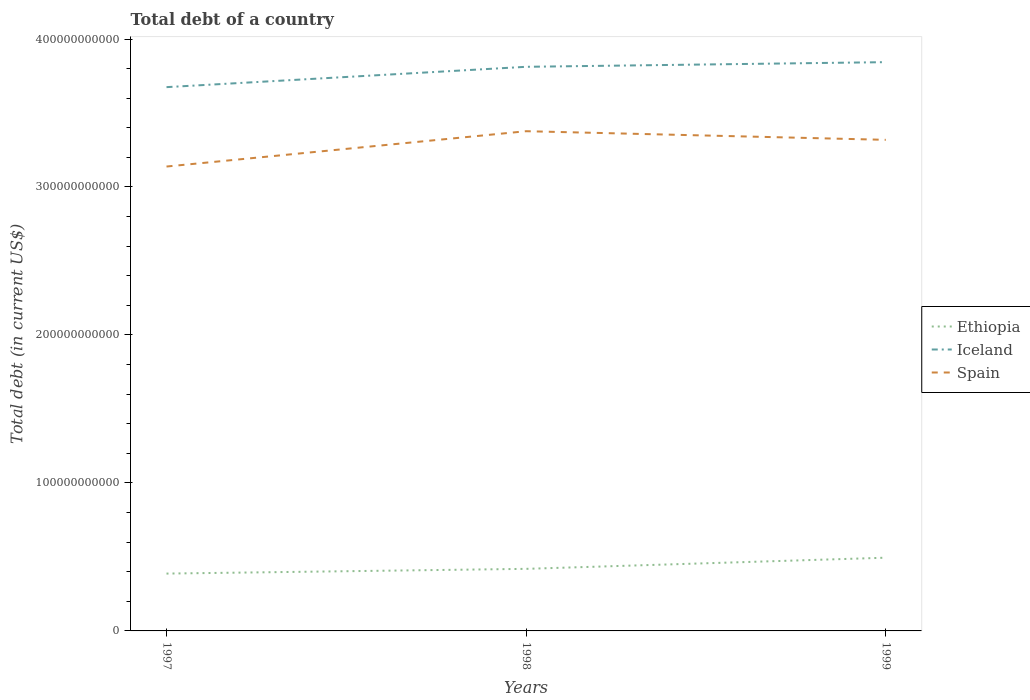Does the line corresponding to Spain intersect with the line corresponding to Ethiopia?
Provide a short and direct response. No. Is the number of lines equal to the number of legend labels?
Offer a very short reply. Yes. Across all years, what is the maximum debt in Iceland?
Offer a terse response. 3.67e+11. In which year was the debt in Spain maximum?
Provide a succinct answer. 1997. What is the total debt in Ethiopia in the graph?
Ensure brevity in your answer.  -7.54e+09. What is the difference between the highest and the second highest debt in Iceland?
Your response must be concise. 1.69e+1. What is the difference between the highest and the lowest debt in Ethiopia?
Provide a short and direct response. 1. How many lines are there?
Offer a very short reply. 3. How many years are there in the graph?
Provide a short and direct response. 3. What is the difference between two consecutive major ticks on the Y-axis?
Your answer should be very brief. 1.00e+11. Does the graph contain grids?
Provide a short and direct response. No. Where does the legend appear in the graph?
Your response must be concise. Center right. What is the title of the graph?
Your answer should be very brief. Total debt of a country. Does "Tajikistan" appear as one of the legend labels in the graph?
Your response must be concise. No. What is the label or title of the X-axis?
Keep it short and to the point. Years. What is the label or title of the Y-axis?
Your response must be concise. Total debt (in current US$). What is the Total debt (in current US$) in Ethiopia in 1997?
Give a very brief answer. 3.87e+1. What is the Total debt (in current US$) in Iceland in 1997?
Give a very brief answer. 3.67e+11. What is the Total debt (in current US$) in Spain in 1997?
Offer a terse response. 3.14e+11. What is the Total debt (in current US$) of Ethiopia in 1998?
Keep it short and to the point. 4.19e+1. What is the Total debt (in current US$) of Iceland in 1998?
Offer a very short reply. 3.81e+11. What is the Total debt (in current US$) of Spain in 1998?
Ensure brevity in your answer.  3.38e+11. What is the Total debt (in current US$) of Ethiopia in 1999?
Your answer should be compact. 4.95e+1. What is the Total debt (in current US$) of Iceland in 1999?
Keep it short and to the point. 3.84e+11. What is the Total debt (in current US$) of Spain in 1999?
Ensure brevity in your answer.  3.32e+11. Across all years, what is the maximum Total debt (in current US$) in Ethiopia?
Offer a very short reply. 4.95e+1. Across all years, what is the maximum Total debt (in current US$) in Iceland?
Your answer should be compact. 3.84e+11. Across all years, what is the maximum Total debt (in current US$) of Spain?
Ensure brevity in your answer.  3.38e+11. Across all years, what is the minimum Total debt (in current US$) in Ethiopia?
Your answer should be compact. 3.87e+1. Across all years, what is the minimum Total debt (in current US$) in Iceland?
Keep it short and to the point. 3.67e+11. Across all years, what is the minimum Total debt (in current US$) of Spain?
Give a very brief answer. 3.14e+11. What is the total Total debt (in current US$) of Ethiopia in the graph?
Your answer should be compact. 1.30e+11. What is the total Total debt (in current US$) in Iceland in the graph?
Ensure brevity in your answer.  1.13e+12. What is the total Total debt (in current US$) of Spain in the graph?
Your response must be concise. 9.83e+11. What is the difference between the Total debt (in current US$) in Ethiopia in 1997 and that in 1998?
Your answer should be very brief. -3.20e+09. What is the difference between the Total debt (in current US$) of Iceland in 1997 and that in 1998?
Provide a short and direct response. -1.37e+1. What is the difference between the Total debt (in current US$) in Spain in 1997 and that in 1998?
Your answer should be compact. -2.39e+1. What is the difference between the Total debt (in current US$) in Ethiopia in 1997 and that in 1999?
Your answer should be very brief. -1.07e+1. What is the difference between the Total debt (in current US$) in Iceland in 1997 and that in 1999?
Your answer should be compact. -1.69e+1. What is the difference between the Total debt (in current US$) of Spain in 1997 and that in 1999?
Offer a terse response. -1.80e+1. What is the difference between the Total debt (in current US$) in Ethiopia in 1998 and that in 1999?
Keep it short and to the point. -7.54e+09. What is the difference between the Total debt (in current US$) in Iceland in 1998 and that in 1999?
Your answer should be compact. -3.15e+09. What is the difference between the Total debt (in current US$) of Spain in 1998 and that in 1999?
Your response must be concise. 5.84e+09. What is the difference between the Total debt (in current US$) of Ethiopia in 1997 and the Total debt (in current US$) of Iceland in 1998?
Offer a very short reply. -3.42e+11. What is the difference between the Total debt (in current US$) in Ethiopia in 1997 and the Total debt (in current US$) in Spain in 1998?
Provide a succinct answer. -2.99e+11. What is the difference between the Total debt (in current US$) in Iceland in 1997 and the Total debt (in current US$) in Spain in 1998?
Your response must be concise. 2.98e+1. What is the difference between the Total debt (in current US$) in Ethiopia in 1997 and the Total debt (in current US$) in Iceland in 1999?
Your answer should be very brief. -3.46e+11. What is the difference between the Total debt (in current US$) of Ethiopia in 1997 and the Total debt (in current US$) of Spain in 1999?
Provide a short and direct response. -2.93e+11. What is the difference between the Total debt (in current US$) in Iceland in 1997 and the Total debt (in current US$) in Spain in 1999?
Offer a terse response. 3.56e+1. What is the difference between the Total debt (in current US$) of Ethiopia in 1998 and the Total debt (in current US$) of Iceland in 1999?
Give a very brief answer. -3.42e+11. What is the difference between the Total debt (in current US$) of Ethiopia in 1998 and the Total debt (in current US$) of Spain in 1999?
Keep it short and to the point. -2.90e+11. What is the difference between the Total debt (in current US$) of Iceland in 1998 and the Total debt (in current US$) of Spain in 1999?
Offer a terse response. 4.94e+1. What is the average Total debt (in current US$) in Ethiopia per year?
Your answer should be compact. 4.34e+1. What is the average Total debt (in current US$) in Iceland per year?
Ensure brevity in your answer.  3.78e+11. What is the average Total debt (in current US$) in Spain per year?
Keep it short and to the point. 3.28e+11. In the year 1997, what is the difference between the Total debt (in current US$) in Ethiopia and Total debt (in current US$) in Iceland?
Give a very brief answer. -3.29e+11. In the year 1997, what is the difference between the Total debt (in current US$) of Ethiopia and Total debt (in current US$) of Spain?
Ensure brevity in your answer.  -2.75e+11. In the year 1997, what is the difference between the Total debt (in current US$) in Iceland and Total debt (in current US$) in Spain?
Your answer should be very brief. 5.37e+1. In the year 1998, what is the difference between the Total debt (in current US$) in Ethiopia and Total debt (in current US$) in Iceland?
Ensure brevity in your answer.  -3.39e+11. In the year 1998, what is the difference between the Total debt (in current US$) of Ethiopia and Total debt (in current US$) of Spain?
Give a very brief answer. -2.96e+11. In the year 1998, what is the difference between the Total debt (in current US$) in Iceland and Total debt (in current US$) in Spain?
Give a very brief answer. 4.35e+1. In the year 1999, what is the difference between the Total debt (in current US$) in Ethiopia and Total debt (in current US$) in Iceland?
Your answer should be compact. -3.35e+11. In the year 1999, what is the difference between the Total debt (in current US$) in Ethiopia and Total debt (in current US$) in Spain?
Give a very brief answer. -2.82e+11. In the year 1999, what is the difference between the Total debt (in current US$) in Iceland and Total debt (in current US$) in Spain?
Give a very brief answer. 5.25e+1. What is the ratio of the Total debt (in current US$) of Ethiopia in 1997 to that in 1998?
Provide a short and direct response. 0.92. What is the ratio of the Total debt (in current US$) of Spain in 1997 to that in 1998?
Your response must be concise. 0.93. What is the ratio of the Total debt (in current US$) in Ethiopia in 1997 to that in 1999?
Ensure brevity in your answer.  0.78. What is the ratio of the Total debt (in current US$) of Iceland in 1997 to that in 1999?
Offer a very short reply. 0.96. What is the ratio of the Total debt (in current US$) in Spain in 1997 to that in 1999?
Your answer should be very brief. 0.95. What is the ratio of the Total debt (in current US$) in Ethiopia in 1998 to that in 1999?
Offer a very short reply. 0.85. What is the ratio of the Total debt (in current US$) of Spain in 1998 to that in 1999?
Give a very brief answer. 1.02. What is the difference between the highest and the second highest Total debt (in current US$) in Ethiopia?
Your answer should be very brief. 7.54e+09. What is the difference between the highest and the second highest Total debt (in current US$) in Iceland?
Make the answer very short. 3.15e+09. What is the difference between the highest and the second highest Total debt (in current US$) in Spain?
Offer a very short reply. 5.84e+09. What is the difference between the highest and the lowest Total debt (in current US$) in Ethiopia?
Your answer should be compact. 1.07e+1. What is the difference between the highest and the lowest Total debt (in current US$) of Iceland?
Your answer should be compact. 1.69e+1. What is the difference between the highest and the lowest Total debt (in current US$) in Spain?
Your answer should be compact. 2.39e+1. 